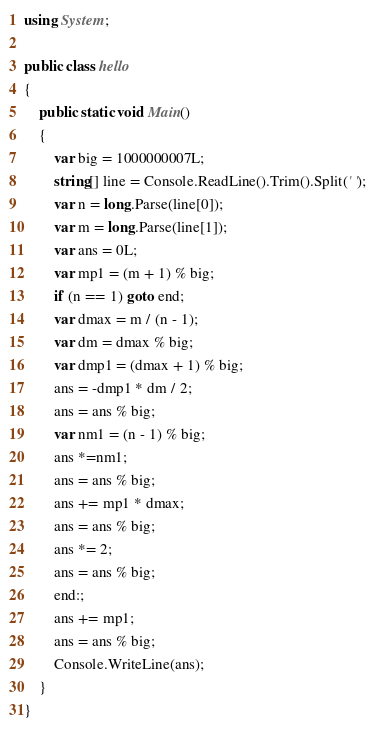Convert code to text. <code><loc_0><loc_0><loc_500><loc_500><_C#_>using System;

public class hello
{
    public static void Main()
    {
        var big = 1000000007L;
        string[] line = Console.ReadLine().Trim().Split(' ');
        var n = long.Parse(line[0]);
        var m = long.Parse(line[1]);
        var ans = 0L;
        var mp1 = (m + 1) % big;
        if (n == 1) goto end;
        var dmax = m / (n - 1);
        var dm = dmax % big;
        var dmp1 = (dmax + 1) % big;
        ans = -dmp1 * dm / 2;
        ans = ans % big;
        var nm1 = (n - 1) % big;
        ans *=nm1;
        ans = ans % big;
        ans += mp1 * dmax;
        ans = ans % big;
        ans *= 2;
        ans = ans % big;
        end:;
        ans += mp1;
        ans = ans % big;
        Console.WriteLine(ans);
    }
}</code> 